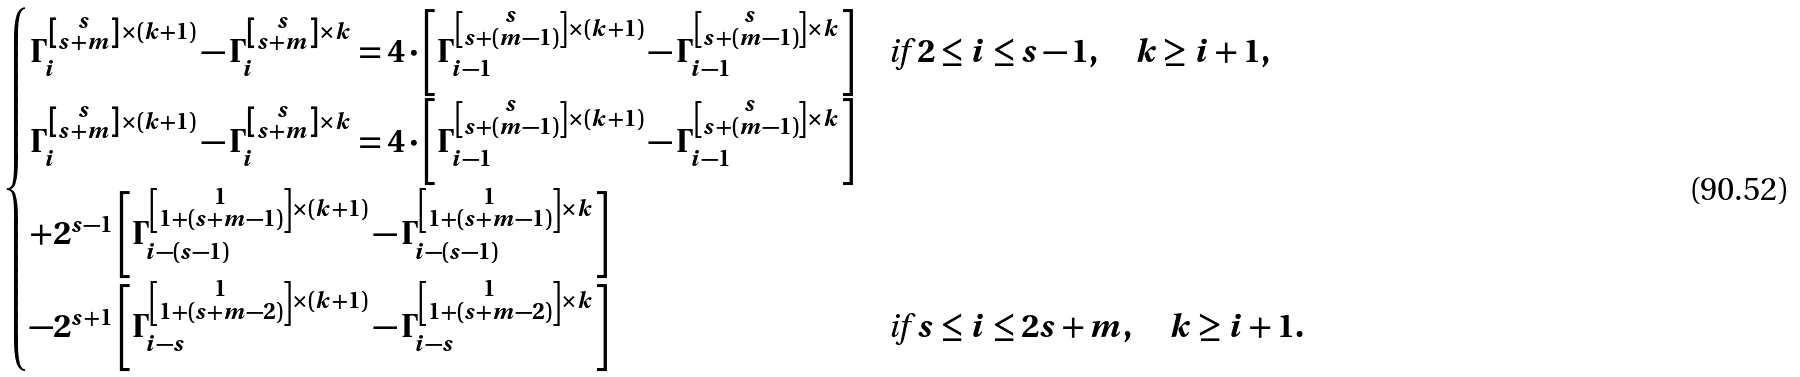Convert formula to latex. <formula><loc_0><loc_0><loc_500><loc_500>\begin{cases} \Gamma _ { i } ^ { \left [ \substack { s \\ s + m } \right ] \times ( k + 1 ) } - \Gamma _ { i } ^ { \left [ \substack { s \\ s + m } \right ] \times k } = 4 \cdot \left [ \Gamma _ { i - 1 } ^ { \left [ \substack { s \\ s + ( m - 1 ) } \right ] \times ( k + 1 ) } - \Gamma _ { i - 1 } ^ { \left [ \substack { s \\ s + ( m - 1 ) } \right ] \times k } \right ] & \text {if } 2 \leq i \leq s - 1 , \quad k \geq i + 1 , \\ \Gamma _ { i } ^ { \left [ \substack { s \\ s + m } \right ] \times ( k + 1 ) } - \Gamma _ { i } ^ { \left [ \substack { s \\ s + m } \right ] \times k } = 4 \cdot \left [ \Gamma _ { i - 1 } ^ { \left [ \substack { s \\ s + ( m - 1 ) } \right ] \times ( k + 1 ) } - \Gamma _ { i - 1 } ^ { \left [ \substack { s \\ s + ( m - 1 ) } \right ] \times k } \right ] \\ + 2 ^ { s - 1 } \left [ \Gamma _ { i - ( s - 1 ) } ^ { \left [ \substack { 1 \\ 1 + ( s + m - 1 ) } \right ] \times ( k + 1 ) } - \Gamma _ { i - ( s - 1 ) } ^ { \left [ \substack { 1 \\ 1 + ( s + m - 1 ) } \right ] \times k } \right ] \\ - 2 ^ { s + 1 } \left [ \Gamma _ { i - s } ^ { \left [ \substack { 1 \\ 1 + ( s + m - 2 ) } \right ] \times ( k + 1 ) } - \Gamma _ { i - s } ^ { \left [ \substack { 1 \\ 1 + ( s + m - 2 ) } \right ] \times k } \right ] & \text {if } s \leq i \leq 2 s + m , \quad k \geq i + 1 . \end{cases}</formula> 